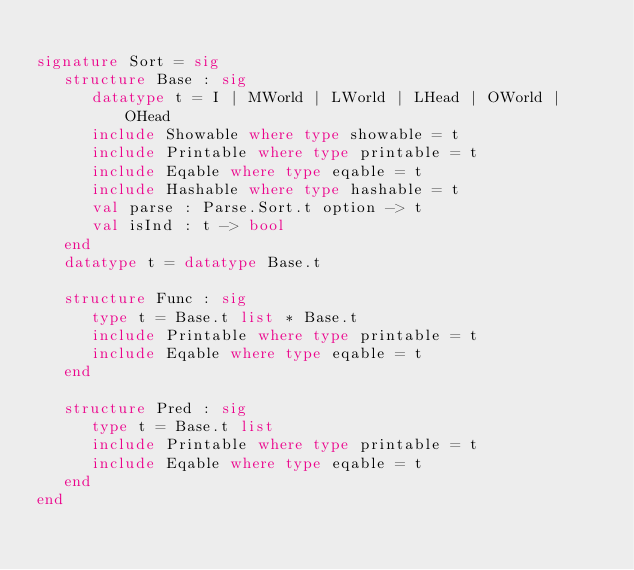Convert code to text. <code><loc_0><loc_0><loc_500><loc_500><_SML_>
signature Sort = sig
   structure Base : sig
      datatype t = I | MWorld | LWorld | LHead | OWorld | OHead
      include Showable where type showable = t
      include Printable where type printable = t
      include Eqable where type eqable = t
      include Hashable where type hashable = t
      val parse : Parse.Sort.t option -> t
      val isInd : t -> bool
   end
   datatype t = datatype Base.t

   structure Func : sig
      type t = Base.t list * Base.t
      include Printable where type printable = t
      include Eqable where type eqable = t
   end

   structure Pred : sig
      type t = Base.t list
      include Printable where type printable = t
      include Eqable where type eqable = t
   end
end
</code> 